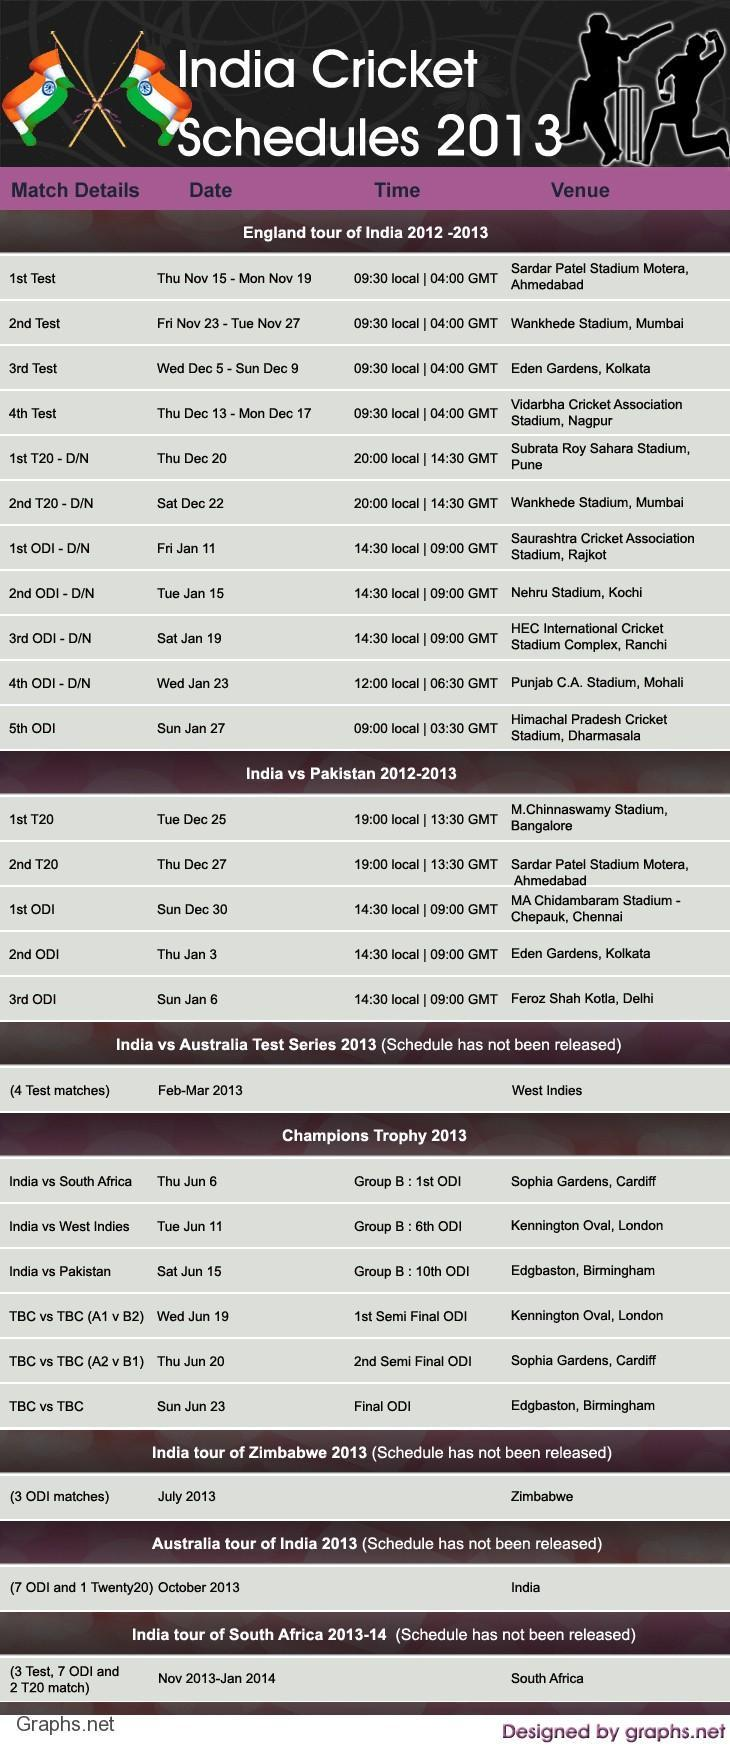How many ODIs were scheduled during the England tour of India 2012-2013?
Answer the question with a short phrase. 5 When was the first ODI scheduled between India & Pakistan in 2012-2013? Sun Dec 30 How many test matches were scheduled during the England tour of India 2012-2013? 4 How many ODIs were scheduled between India & Pakistan in 2012-2013? 3 How many Twenty 20 International matches were scheduled during the England tour of India 2012-2013? 2 In which stadium, the first T20 match between India & Pakistan in 2012-2013 was scheduled? M.Chinnaswamy Stadium, Bangalore 